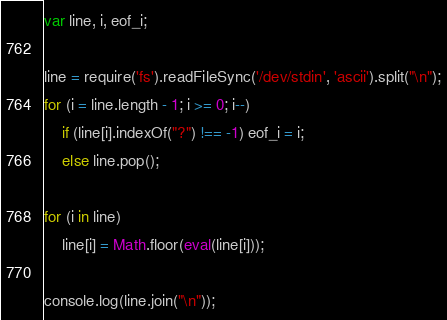Convert code to text. <code><loc_0><loc_0><loc_500><loc_500><_JavaScript_>var line, i, eof_i;

line = require('fs').readFileSync('/dev/stdin', 'ascii').split("\n");
for (i = line.length - 1; i >= 0; i--)
    if (line[i].indexOf("?") !== -1) eof_i = i;
    else line.pop();

for (i in line)
    line[i] = Math.floor(eval(line[i]));

console.log(line.join("\n"));</code> 